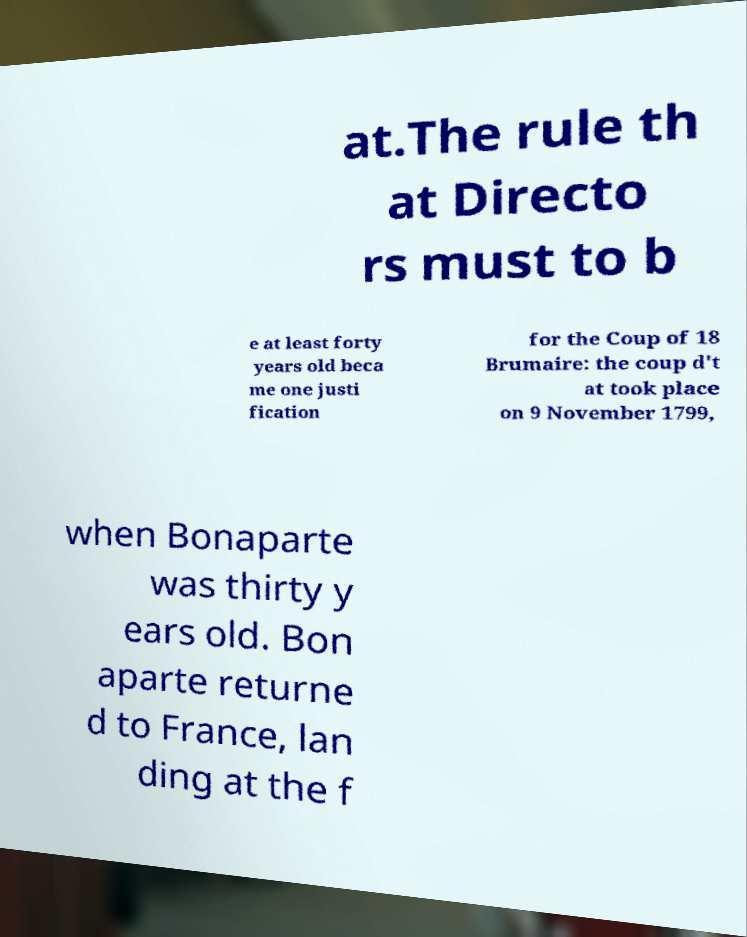What messages or text are displayed in this image? I need them in a readable, typed format. at.The rule th at Directo rs must to b e at least forty years old beca me one justi fication for the Coup of 18 Brumaire: the coup d't at took place on 9 November 1799, when Bonaparte was thirty y ears old. Bon aparte returne d to France, lan ding at the f 